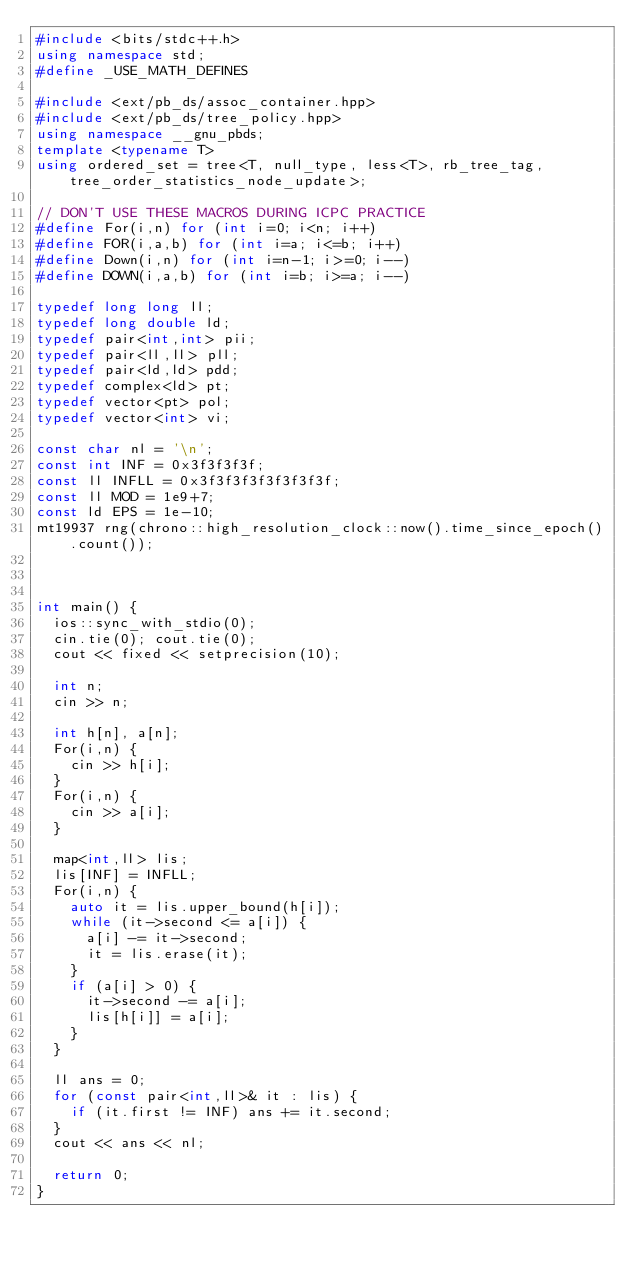<code> <loc_0><loc_0><loc_500><loc_500><_C++_>#include <bits/stdc++.h>
using namespace std;
#define _USE_MATH_DEFINES

#include <ext/pb_ds/assoc_container.hpp>
#include <ext/pb_ds/tree_policy.hpp>
using namespace __gnu_pbds;
template <typename T>
using ordered_set = tree<T, null_type, less<T>, rb_tree_tag, tree_order_statistics_node_update>;

// DON'T USE THESE MACROS DURING ICPC PRACTICE
#define For(i,n) for (int i=0; i<n; i++)
#define FOR(i,a,b) for (int i=a; i<=b; i++)
#define Down(i,n) for (int i=n-1; i>=0; i--)
#define DOWN(i,a,b) for (int i=b; i>=a; i--)

typedef long long ll;
typedef long double ld;
typedef pair<int,int> pii;
typedef pair<ll,ll> pll;
typedef pair<ld,ld> pdd;
typedef complex<ld> pt;
typedef vector<pt> pol;
typedef vector<int> vi;

const char nl = '\n';
const int INF = 0x3f3f3f3f;
const ll INFLL = 0x3f3f3f3f3f3f3f3f;
const ll MOD = 1e9+7;
const ld EPS = 1e-10;
mt19937 rng(chrono::high_resolution_clock::now().time_since_epoch().count());



int main() {
	ios::sync_with_stdio(0);
	cin.tie(0); cout.tie(0);
	cout << fixed << setprecision(10);

	int n;
	cin >> n;

	int h[n], a[n];
	For(i,n) {
		cin >> h[i];
	}
	For(i,n) {
		cin >> a[i];
	}

	map<int,ll> lis;
	lis[INF] = INFLL;
	For(i,n) {
		auto it = lis.upper_bound(h[i]);
		while (it->second <= a[i]) {
			a[i] -= it->second;
			it = lis.erase(it);
		}
		if (a[i] > 0) {
			it->second -= a[i];
			lis[h[i]] = a[i];
		}
	}

	ll ans = 0;
	for (const pair<int,ll>& it : lis) {
		if (it.first != INF) ans += it.second;
	}
	cout << ans << nl;

	return 0;
}
</code> 